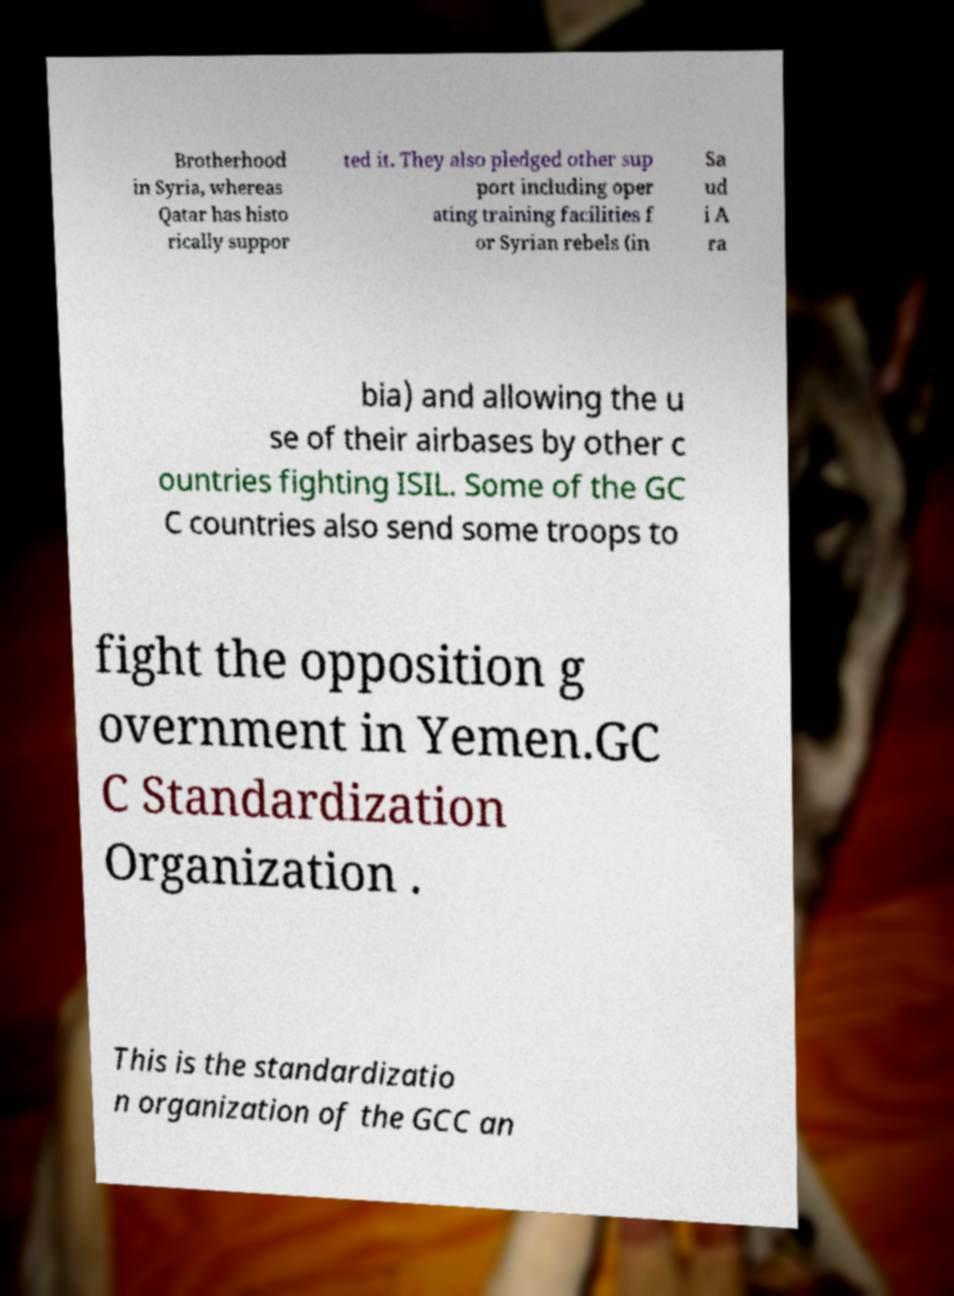For documentation purposes, I need the text within this image transcribed. Could you provide that? Brotherhood in Syria, whereas Qatar has histo rically suppor ted it. They also pledged other sup port including oper ating training facilities f or Syrian rebels (in Sa ud i A ra bia) and allowing the u se of their airbases by other c ountries fighting ISIL. Some of the GC C countries also send some troops to fight the opposition g overnment in Yemen.GC C Standardization Organization . This is the standardizatio n organization of the GCC an 